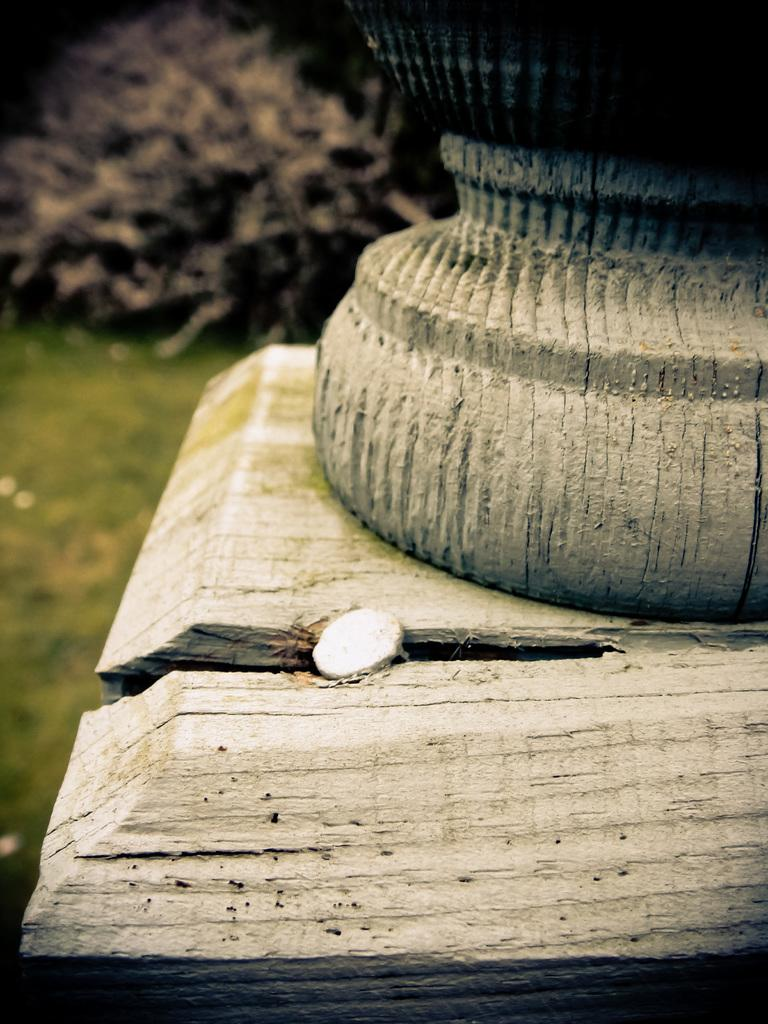What type of objects can be seen in the foreground of the image? There are wooden objects in the foreground of the image. What can be seen in the background of the image? There is greenery in the background of the image, although it is not clear. How many balls are visible in the image? There are no balls present in the image; it features wooden objects in the foreground and greenery in the background. Are there any brothers in the image? There is no reference to any people or siblings in the image, so it cannot be determined if there are any brothers present. 